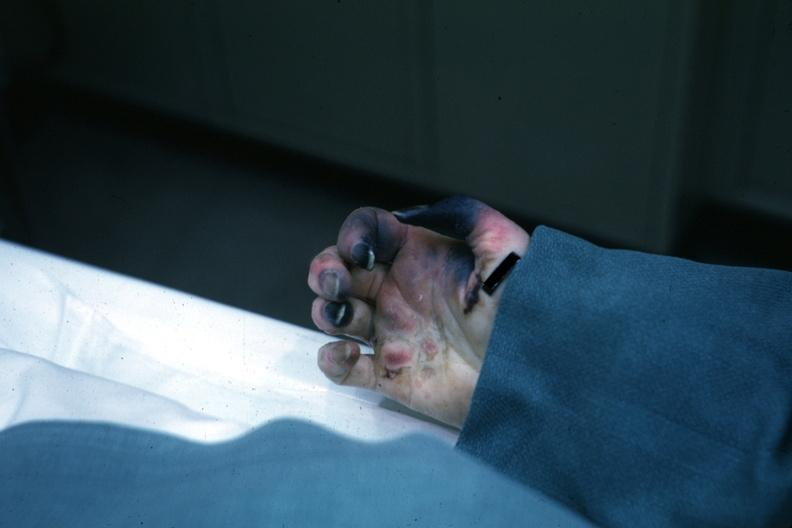s hyalin mass in pituitary which is amyloid there are several slides from this case in this file 23 yowf amyloid limited to brain present?
Answer the question using a single word or phrase. No 